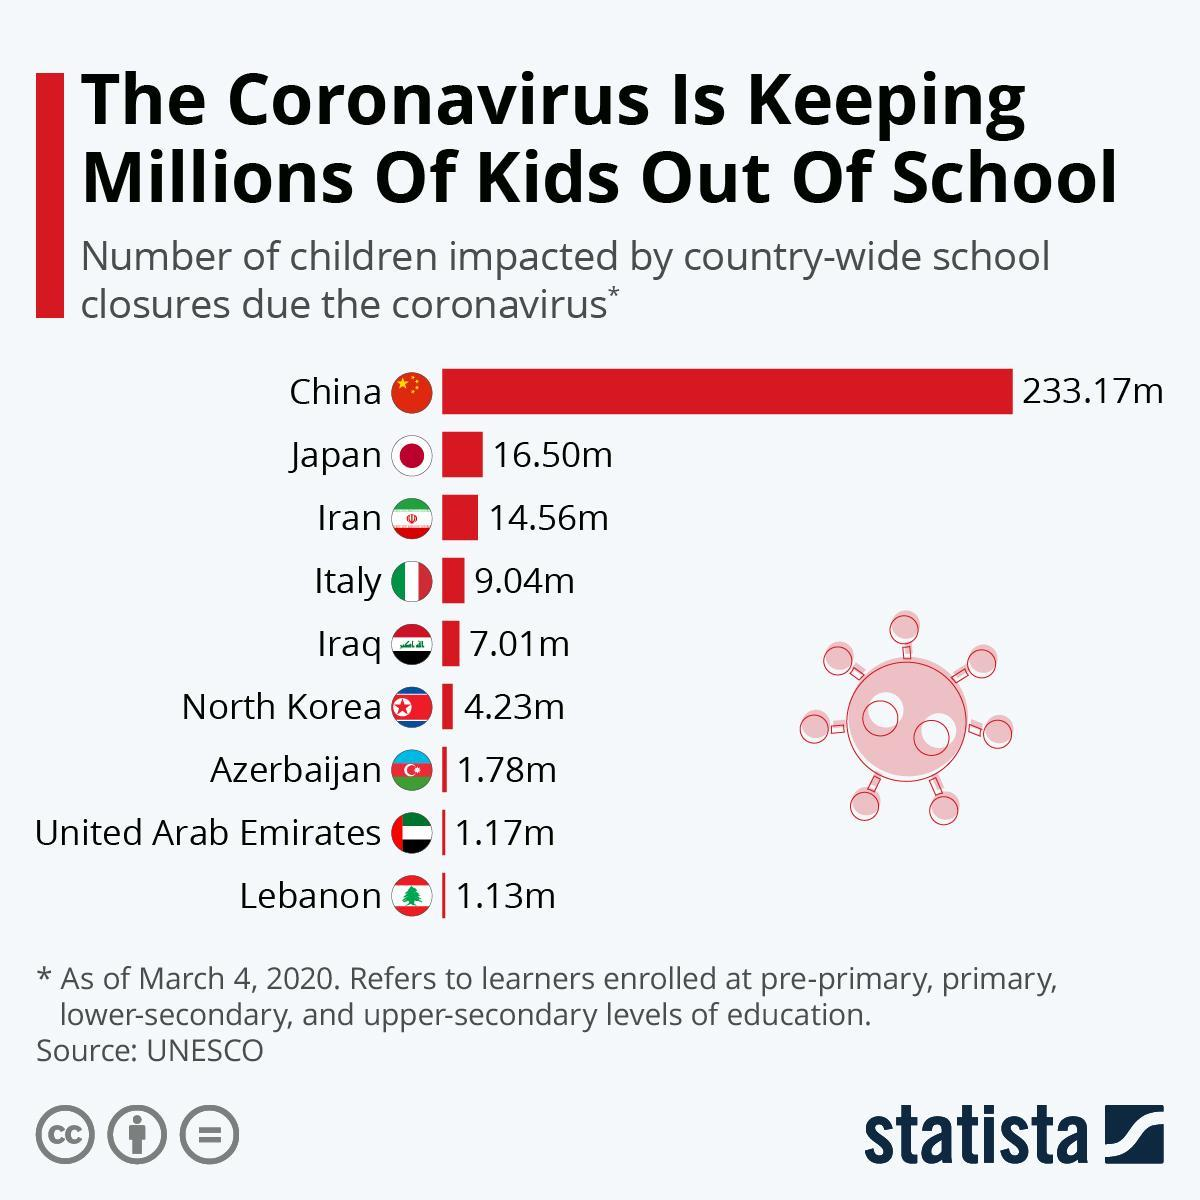Which countries have less than 2 million children impacted due to corona virus?
Answer the question with a short phrase. Azerbaijan, United Arab Emirates, Lebanon Children of which country has been most affected due to school closures? China How many countries are included in the survey? 9 